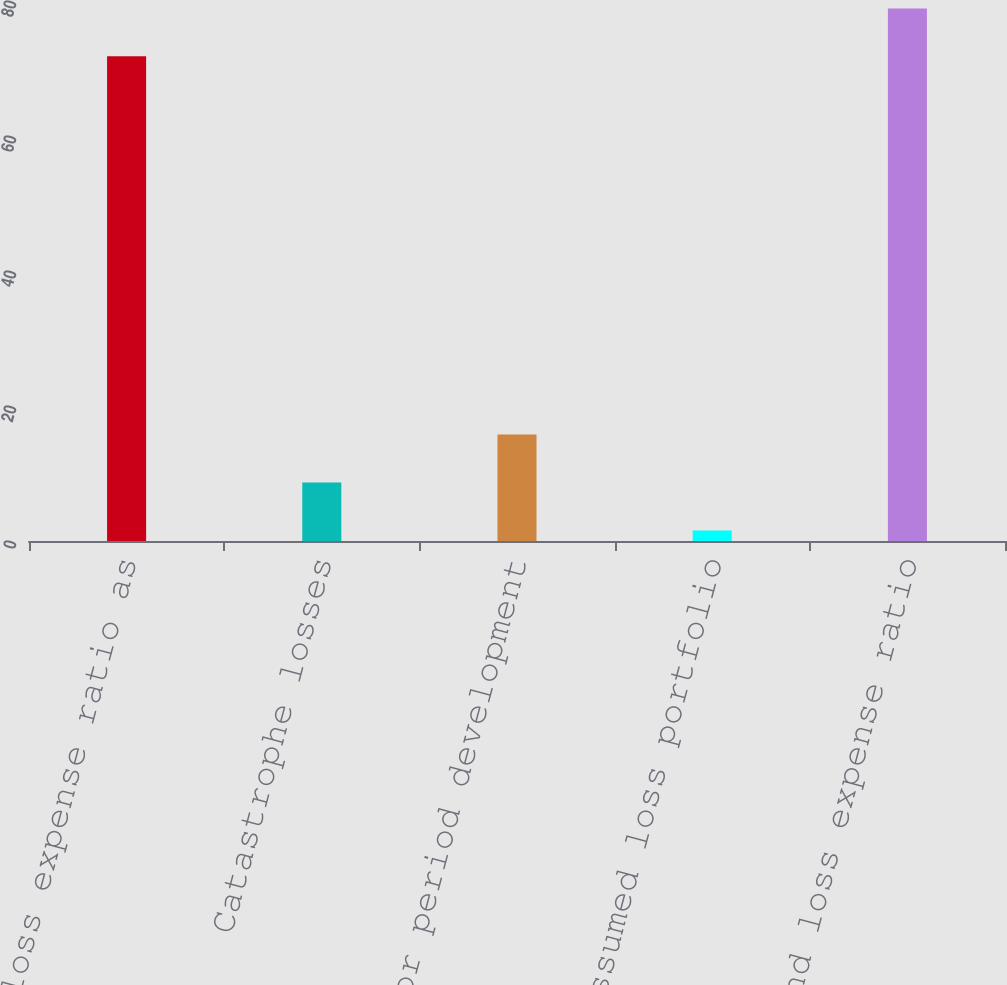Convert chart to OTSL. <chart><loc_0><loc_0><loc_500><loc_500><bar_chart><fcel>Loss and loss expense ratio as<fcel>Catastrophe losses<fcel>Prior period development<fcel>Large assumed loss portfolio<fcel>Loss and loss expense ratio<nl><fcel>71.8<fcel>8.66<fcel>15.76<fcel>1.56<fcel>78.9<nl></chart> 